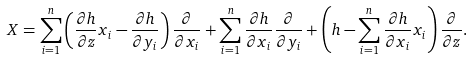<formula> <loc_0><loc_0><loc_500><loc_500>X = \sum _ { i = 1 } ^ { n } \left ( \frac { \partial h } { \partial z } x _ { i } - \frac { \partial h } { \partial y _ { i } } \right ) \frac { \partial } { \partial x _ { i } } + \sum _ { i = 1 } ^ { n } \frac { \partial h } { \partial x _ { i } } \frac { \partial } { \partial y _ { i } } + \left ( h - \sum _ { i = 1 } ^ { n } \frac { \partial h } { \partial x _ { i } } x _ { i } \right ) \frac { \partial } { \partial z } .</formula> 